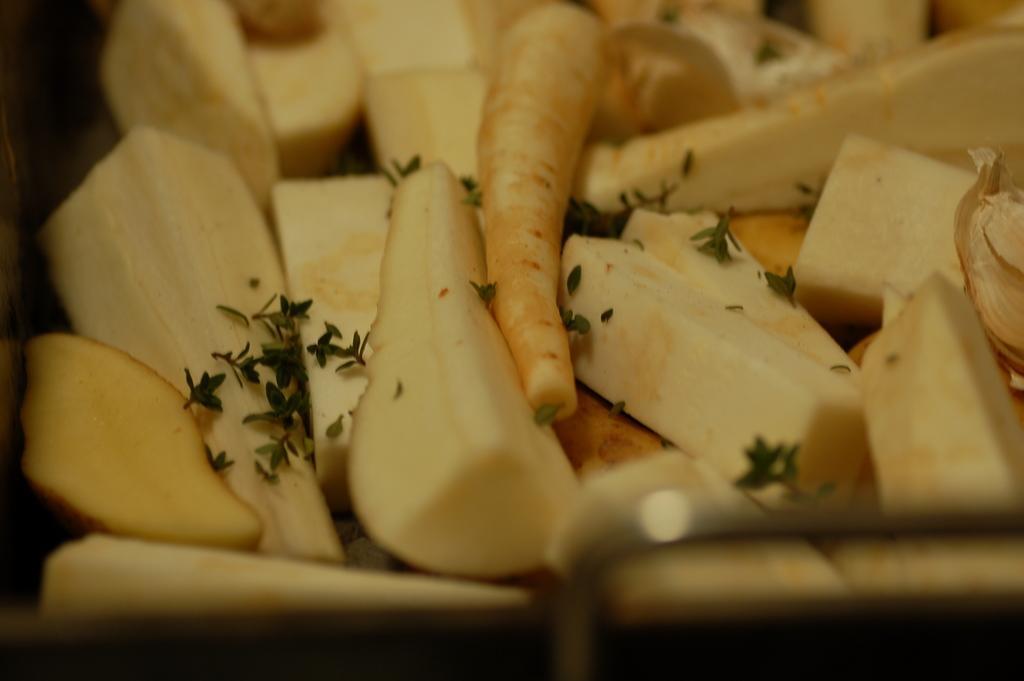Could you give a brief overview of what you see in this image? In the center of the image we can see food items. 